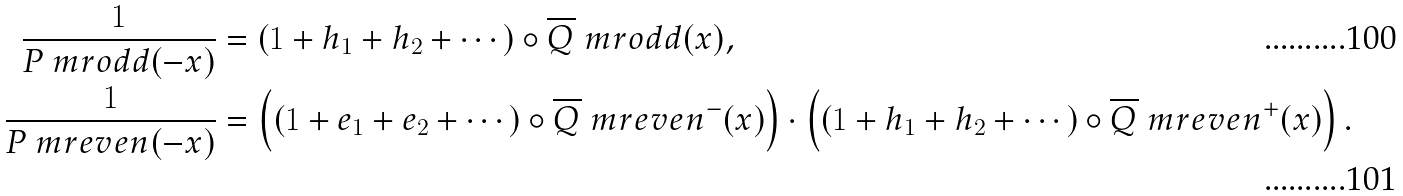<formula> <loc_0><loc_0><loc_500><loc_500>\frac { 1 } { P _ { \ } m r { o d d } ( - x ) } & = ( 1 + h _ { 1 } + h _ { 2 } + \cdots ) \circ \overline { Q } _ { \ } m r { o d d } ( x ) , \\ \frac { 1 } { P _ { \ } m r { e v e n } ( - x ) } & = \left ( ( 1 + e _ { 1 } + e _ { 2 } + \cdots ) \circ \overline { Q } _ { \ } m r { e v e n } ^ { - } ( x ) \right ) \cdot \left ( ( 1 + h _ { 1 } + h _ { 2 } + \cdots ) \circ \overline { Q } _ { \ } m r { e v e n } ^ { + } ( x ) \right ) .</formula> 